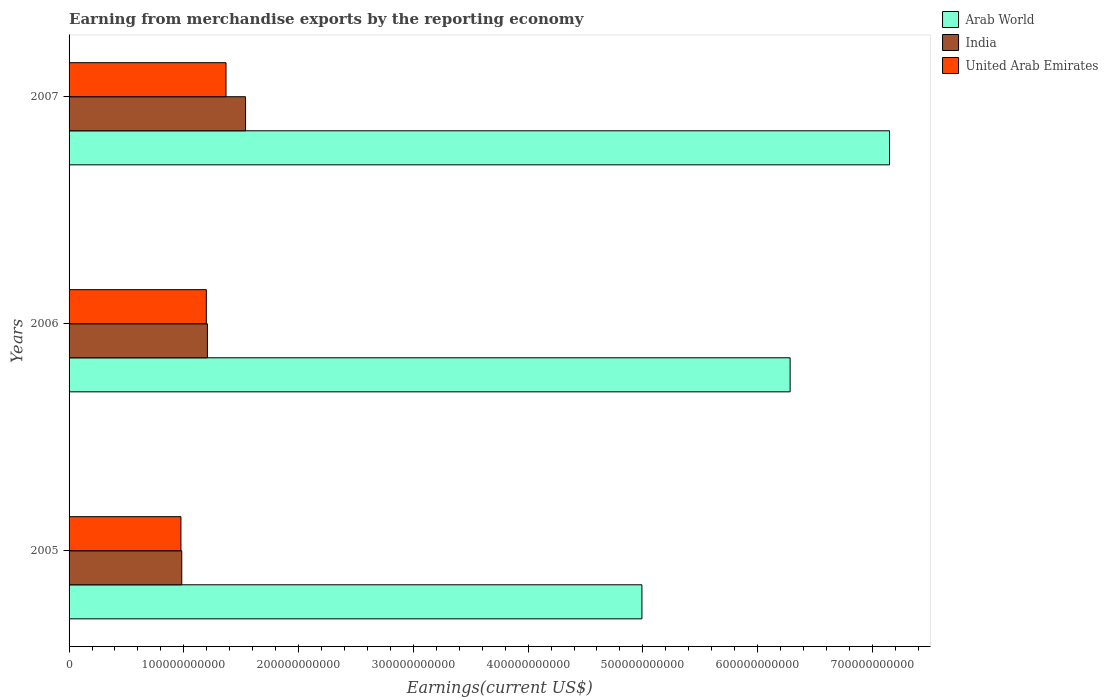How many groups of bars are there?
Ensure brevity in your answer.  3. How many bars are there on the 2nd tick from the bottom?
Keep it short and to the point. 3. In how many cases, is the number of bars for a given year not equal to the number of legend labels?
Your answer should be compact. 0. What is the amount earned from merchandise exports in Arab World in 2007?
Offer a very short reply. 7.15e+11. Across all years, what is the maximum amount earned from merchandise exports in United Arab Emirates?
Provide a succinct answer. 1.37e+11. Across all years, what is the minimum amount earned from merchandise exports in United Arab Emirates?
Keep it short and to the point. 9.75e+1. What is the total amount earned from merchandise exports in India in the graph?
Your response must be concise. 3.73e+11. What is the difference between the amount earned from merchandise exports in United Arab Emirates in 2006 and that in 2007?
Your answer should be very brief. -1.72e+1. What is the difference between the amount earned from merchandise exports in Arab World in 2006 and the amount earned from merchandise exports in United Arab Emirates in 2005?
Provide a short and direct response. 5.31e+11. What is the average amount earned from merchandise exports in United Arab Emirates per year?
Your answer should be compact. 1.18e+11. In the year 2006, what is the difference between the amount earned from merchandise exports in Arab World and amount earned from merchandise exports in India?
Provide a succinct answer. 5.08e+11. In how many years, is the amount earned from merchandise exports in United Arab Emirates greater than 720000000000 US$?
Give a very brief answer. 0. What is the ratio of the amount earned from merchandise exports in Arab World in 2006 to that in 2007?
Ensure brevity in your answer.  0.88. Is the amount earned from merchandise exports in Arab World in 2005 less than that in 2006?
Your answer should be very brief. Yes. Is the difference between the amount earned from merchandise exports in Arab World in 2005 and 2007 greater than the difference between the amount earned from merchandise exports in India in 2005 and 2007?
Your response must be concise. No. What is the difference between the highest and the second highest amount earned from merchandise exports in Arab World?
Offer a terse response. 8.66e+1. What is the difference between the highest and the lowest amount earned from merchandise exports in United Arab Emirates?
Offer a very short reply. 3.93e+1. In how many years, is the amount earned from merchandise exports in United Arab Emirates greater than the average amount earned from merchandise exports in United Arab Emirates taken over all years?
Offer a very short reply. 2. Is the sum of the amount earned from merchandise exports in United Arab Emirates in 2005 and 2007 greater than the maximum amount earned from merchandise exports in India across all years?
Ensure brevity in your answer.  Yes. What does the 2nd bar from the top in 2006 represents?
Provide a short and direct response. India. What does the 1st bar from the bottom in 2007 represents?
Offer a terse response. Arab World. How many bars are there?
Your answer should be compact. 9. Are all the bars in the graph horizontal?
Keep it short and to the point. Yes. How many years are there in the graph?
Offer a terse response. 3. What is the difference between two consecutive major ticks on the X-axis?
Your answer should be very brief. 1.00e+11. Where does the legend appear in the graph?
Your answer should be compact. Top right. How many legend labels are there?
Provide a succinct answer. 3. What is the title of the graph?
Offer a terse response. Earning from merchandise exports by the reporting economy. Does "Azerbaijan" appear as one of the legend labels in the graph?
Your response must be concise. No. What is the label or title of the X-axis?
Make the answer very short. Earnings(current US$). What is the label or title of the Y-axis?
Provide a short and direct response. Years. What is the Earnings(current US$) in Arab World in 2005?
Offer a very short reply. 4.99e+11. What is the Earnings(current US$) of India in 2005?
Provide a short and direct response. 9.82e+1. What is the Earnings(current US$) of United Arab Emirates in 2005?
Provide a succinct answer. 9.75e+1. What is the Earnings(current US$) in Arab World in 2006?
Your answer should be compact. 6.28e+11. What is the Earnings(current US$) in India in 2006?
Provide a short and direct response. 1.21e+11. What is the Earnings(current US$) in United Arab Emirates in 2006?
Give a very brief answer. 1.20e+11. What is the Earnings(current US$) of Arab World in 2007?
Offer a very short reply. 7.15e+11. What is the Earnings(current US$) in India in 2007?
Ensure brevity in your answer.  1.54e+11. What is the Earnings(current US$) in United Arab Emirates in 2007?
Keep it short and to the point. 1.37e+11. Across all years, what is the maximum Earnings(current US$) in Arab World?
Keep it short and to the point. 7.15e+11. Across all years, what is the maximum Earnings(current US$) of India?
Your answer should be very brief. 1.54e+11. Across all years, what is the maximum Earnings(current US$) in United Arab Emirates?
Your response must be concise. 1.37e+11. Across all years, what is the minimum Earnings(current US$) in Arab World?
Your response must be concise. 4.99e+11. Across all years, what is the minimum Earnings(current US$) of India?
Keep it short and to the point. 9.82e+1. Across all years, what is the minimum Earnings(current US$) of United Arab Emirates?
Offer a very short reply. 9.75e+1. What is the total Earnings(current US$) of Arab World in the graph?
Keep it short and to the point. 1.84e+12. What is the total Earnings(current US$) of India in the graph?
Your answer should be compact. 3.73e+11. What is the total Earnings(current US$) of United Arab Emirates in the graph?
Offer a terse response. 3.54e+11. What is the difference between the Earnings(current US$) of Arab World in 2005 and that in 2006?
Your response must be concise. -1.29e+11. What is the difference between the Earnings(current US$) in India in 2005 and that in 2006?
Your answer should be compact. -2.23e+1. What is the difference between the Earnings(current US$) in United Arab Emirates in 2005 and that in 2006?
Offer a terse response. -2.21e+1. What is the difference between the Earnings(current US$) in Arab World in 2005 and that in 2007?
Ensure brevity in your answer.  -2.16e+11. What is the difference between the Earnings(current US$) in India in 2005 and that in 2007?
Provide a short and direct response. -5.56e+1. What is the difference between the Earnings(current US$) of United Arab Emirates in 2005 and that in 2007?
Provide a short and direct response. -3.93e+1. What is the difference between the Earnings(current US$) of Arab World in 2006 and that in 2007?
Ensure brevity in your answer.  -8.66e+1. What is the difference between the Earnings(current US$) in India in 2006 and that in 2007?
Your answer should be very brief. -3.32e+1. What is the difference between the Earnings(current US$) in United Arab Emirates in 2006 and that in 2007?
Offer a very short reply. -1.72e+1. What is the difference between the Earnings(current US$) of Arab World in 2005 and the Earnings(current US$) of India in 2006?
Your response must be concise. 3.79e+11. What is the difference between the Earnings(current US$) in Arab World in 2005 and the Earnings(current US$) in United Arab Emirates in 2006?
Give a very brief answer. 3.80e+11. What is the difference between the Earnings(current US$) in India in 2005 and the Earnings(current US$) in United Arab Emirates in 2006?
Give a very brief answer. -2.14e+1. What is the difference between the Earnings(current US$) in Arab World in 2005 and the Earnings(current US$) in India in 2007?
Your answer should be very brief. 3.45e+11. What is the difference between the Earnings(current US$) in Arab World in 2005 and the Earnings(current US$) in United Arab Emirates in 2007?
Keep it short and to the point. 3.62e+11. What is the difference between the Earnings(current US$) in India in 2005 and the Earnings(current US$) in United Arab Emirates in 2007?
Offer a terse response. -3.86e+1. What is the difference between the Earnings(current US$) of Arab World in 2006 and the Earnings(current US$) of India in 2007?
Offer a terse response. 4.75e+11. What is the difference between the Earnings(current US$) in Arab World in 2006 and the Earnings(current US$) in United Arab Emirates in 2007?
Provide a succinct answer. 4.92e+11. What is the difference between the Earnings(current US$) of India in 2006 and the Earnings(current US$) of United Arab Emirates in 2007?
Provide a succinct answer. -1.62e+1. What is the average Earnings(current US$) of Arab World per year?
Your answer should be compact. 6.14e+11. What is the average Earnings(current US$) in India per year?
Provide a succinct answer. 1.24e+11. What is the average Earnings(current US$) of United Arab Emirates per year?
Provide a short and direct response. 1.18e+11. In the year 2005, what is the difference between the Earnings(current US$) of Arab World and Earnings(current US$) of India?
Provide a succinct answer. 4.01e+11. In the year 2005, what is the difference between the Earnings(current US$) in Arab World and Earnings(current US$) in United Arab Emirates?
Provide a succinct answer. 4.02e+11. In the year 2005, what is the difference between the Earnings(current US$) in India and Earnings(current US$) in United Arab Emirates?
Offer a terse response. 7.24e+08. In the year 2006, what is the difference between the Earnings(current US$) of Arab World and Earnings(current US$) of India?
Offer a terse response. 5.08e+11. In the year 2006, what is the difference between the Earnings(current US$) in Arab World and Earnings(current US$) in United Arab Emirates?
Make the answer very short. 5.09e+11. In the year 2006, what is the difference between the Earnings(current US$) of India and Earnings(current US$) of United Arab Emirates?
Offer a terse response. 9.38e+08. In the year 2007, what is the difference between the Earnings(current US$) in Arab World and Earnings(current US$) in India?
Your response must be concise. 5.61e+11. In the year 2007, what is the difference between the Earnings(current US$) of Arab World and Earnings(current US$) of United Arab Emirates?
Keep it short and to the point. 5.78e+11. In the year 2007, what is the difference between the Earnings(current US$) in India and Earnings(current US$) in United Arab Emirates?
Provide a succinct answer. 1.70e+1. What is the ratio of the Earnings(current US$) of Arab World in 2005 to that in 2006?
Offer a terse response. 0.79. What is the ratio of the Earnings(current US$) in India in 2005 to that in 2006?
Offer a very short reply. 0.81. What is the ratio of the Earnings(current US$) of United Arab Emirates in 2005 to that in 2006?
Give a very brief answer. 0.82. What is the ratio of the Earnings(current US$) of Arab World in 2005 to that in 2007?
Offer a terse response. 0.7. What is the ratio of the Earnings(current US$) of India in 2005 to that in 2007?
Provide a succinct answer. 0.64. What is the ratio of the Earnings(current US$) of United Arab Emirates in 2005 to that in 2007?
Provide a short and direct response. 0.71. What is the ratio of the Earnings(current US$) of Arab World in 2006 to that in 2007?
Ensure brevity in your answer.  0.88. What is the ratio of the Earnings(current US$) in India in 2006 to that in 2007?
Your response must be concise. 0.78. What is the ratio of the Earnings(current US$) in United Arab Emirates in 2006 to that in 2007?
Make the answer very short. 0.87. What is the difference between the highest and the second highest Earnings(current US$) in Arab World?
Provide a short and direct response. 8.66e+1. What is the difference between the highest and the second highest Earnings(current US$) of India?
Your response must be concise. 3.32e+1. What is the difference between the highest and the second highest Earnings(current US$) in United Arab Emirates?
Your answer should be very brief. 1.72e+1. What is the difference between the highest and the lowest Earnings(current US$) of Arab World?
Your answer should be compact. 2.16e+11. What is the difference between the highest and the lowest Earnings(current US$) in India?
Offer a terse response. 5.56e+1. What is the difference between the highest and the lowest Earnings(current US$) of United Arab Emirates?
Provide a succinct answer. 3.93e+1. 